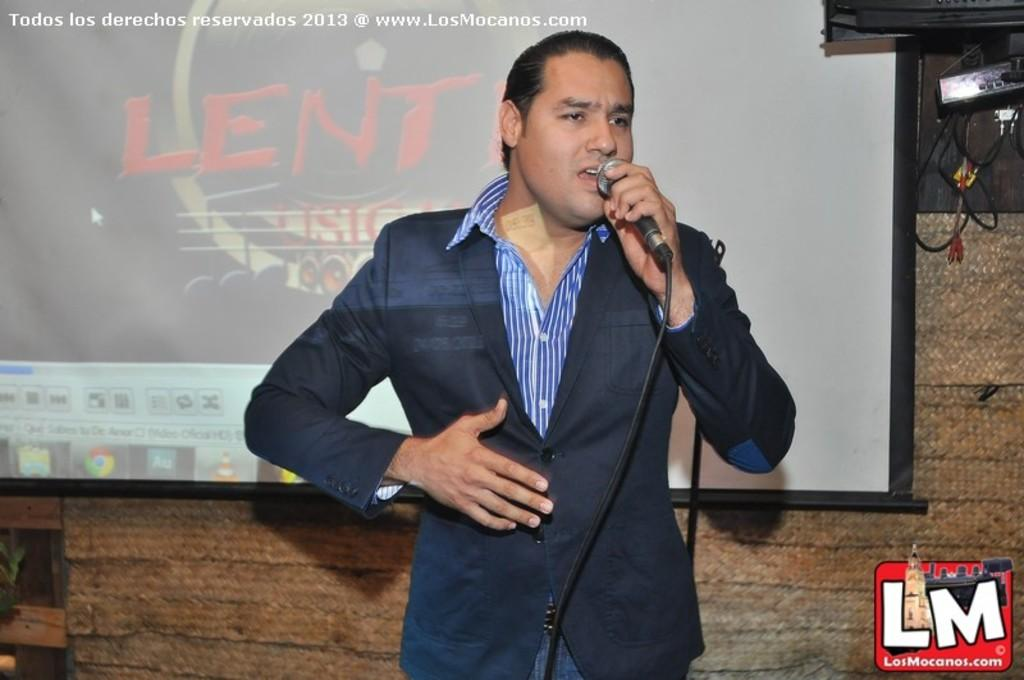Who is the person in the image? There is a man in the image. What is the man wearing? The man is wearing a blazer. What is the man holding in the image? The man is holding a microphone. What is the man doing in the image? The man is talking. What can be seen in the background of the image? There is a projector screen and a wall in the background of the image. How many hens are visible on the projector screen in the image? There are no hens visible on the projector screen in the image. What type of butter is being used to grease the wall in the background? There is no butter present in the image, and the wall is not being greased. 